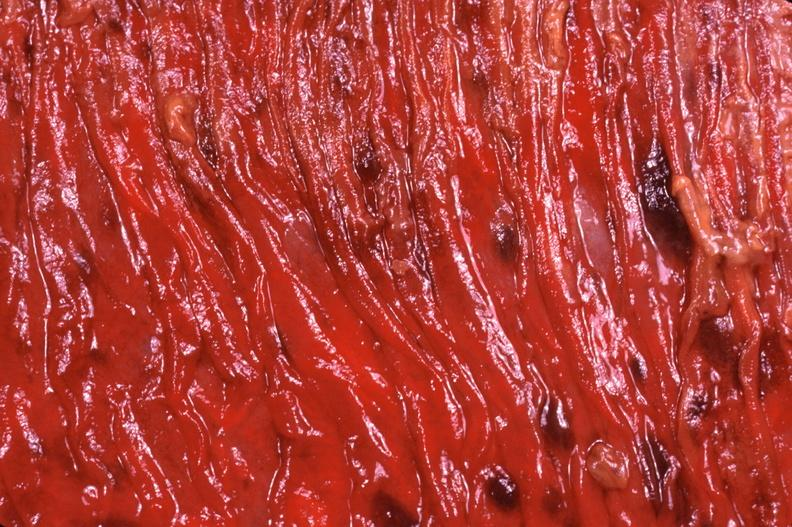s gastrointestinal present?
Answer the question using a single word or phrase. Yes 